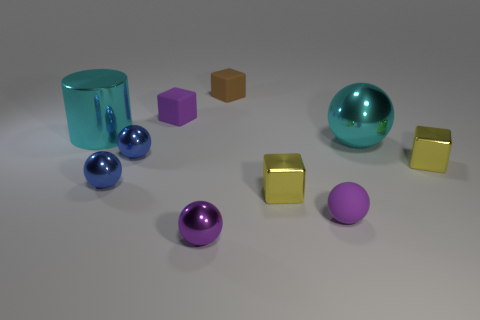Subtract all brown cubes. How many cubes are left? 3 Subtract all metal spheres. How many spheres are left? 1 Subtract 1 blocks. How many blocks are left? 3 Subtract all gray spheres. Subtract all gray cubes. How many spheres are left? 5 Subtract 0 green cylinders. How many objects are left? 10 Subtract all cubes. How many objects are left? 6 Subtract all large cylinders. Subtract all large cyan balls. How many objects are left? 8 Add 7 rubber cubes. How many rubber cubes are left? 9 Add 1 cyan spheres. How many cyan spheres exist? 2 